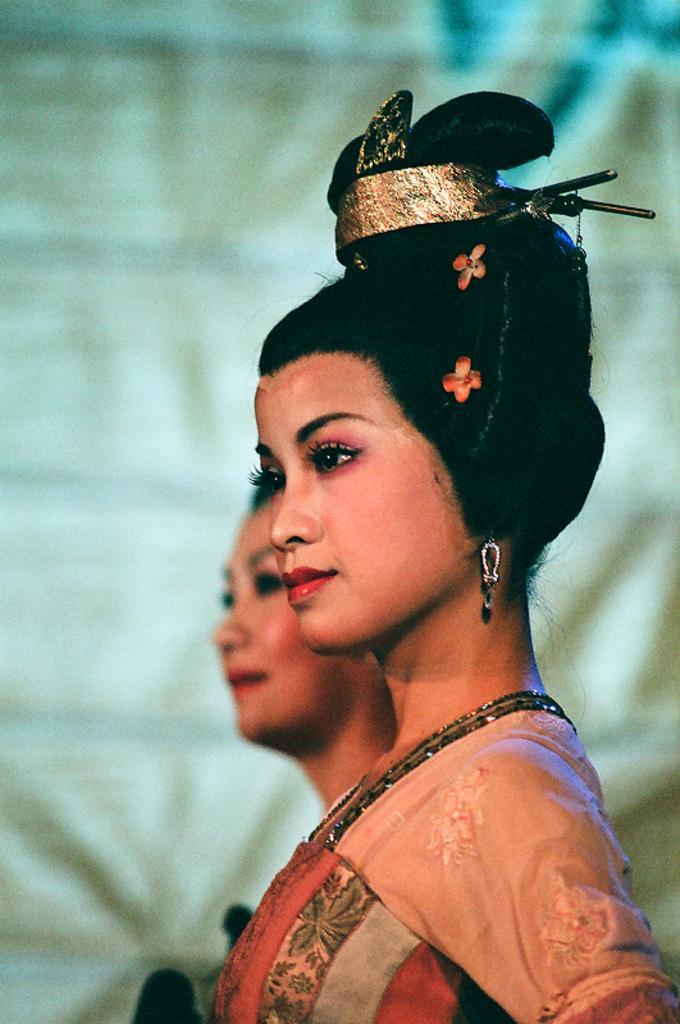How would you summarize this image in a sentence or two? In the center of the image we can see two ladies are standing. In the background of the image we can see a cloth. 